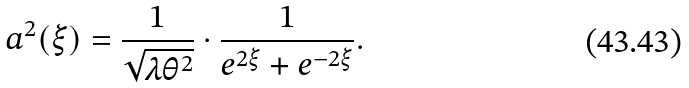<formula> <loc_0><loc_0><loc_500><loc_500>a ^ { 2 } ( \xi ) = \frac { 1 } { \sqrt { \lambda \theta ^ { 2 } } } \cdot \frac { 1 } { e ^ { 2 \xi } + e ^ { - 2 \xi } } .</formula> 